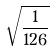Convert formula to latex. <formula><loc_0><loc_0><loc_500><loc_500>\sqrt { \frac { 1 } { 1 2 6 } }</formula> 